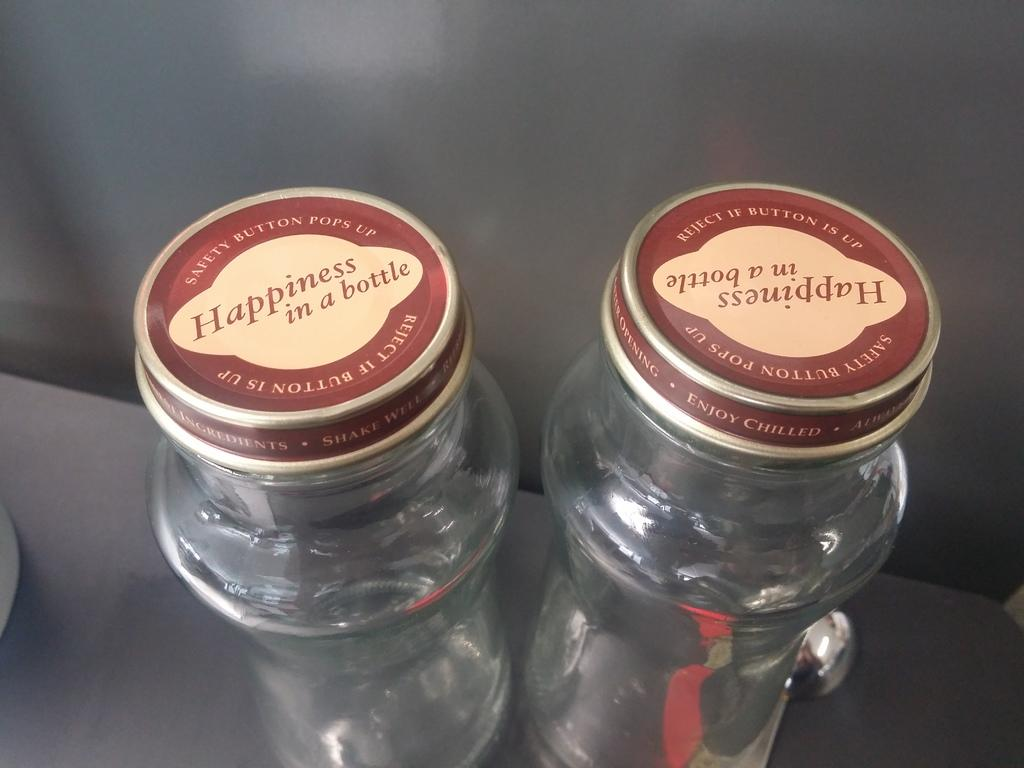How many bottles can be seen in the image? There are two bottles in the image. What material are the bottles made of? The bottles are made of glass. What is written on the caps of the bottles? There is text printed on the caps of the bottles. Where are the bottles located in the image? The bottles are placed on a table. What can be seen in the background of the image? There is a wall in the background of the image. Are there any mittens or pets visible in the image? No, there are no mittens or pets present in the image. What type of crib is shown in the image? There is no crib present in the image. 